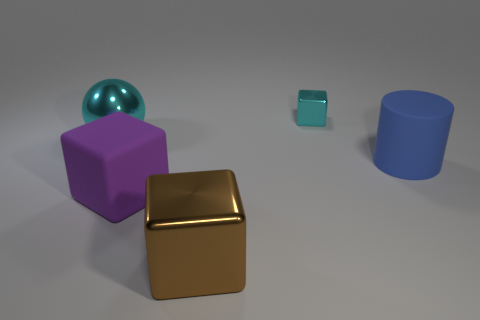Add 2 large blocks. How many objects exist? 7 Subtract all large purple matte blocks. How many blocks are left? 2 Subtract all blocks. How many objects are left? 2 Subtract 1 cylinders. How many cylinders are left? 0 Subtract all red spheres. Subtract all purple cylinders. How many spheres are left? 1 Subtract all red cubes. How many red balls are left? 0 Subtract all blue matte objects. Subtract all gray matte cubes. How many objects are left? 4 Add 5 small cubes. How many small cubes are left? 6 Add 1 big blue objects. How many big blue objects exist? 2 Subtract 0 green blocks. How many objects are left? 5 